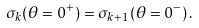<formula> <loc_0><loc_0><loc_500><loc_500>\sigma _ { k } ( \theta = 0 ^ { + } ) = \sigma _ { k + 1 } ( \theta = 0 ^ { - } ) \, .</formula> 